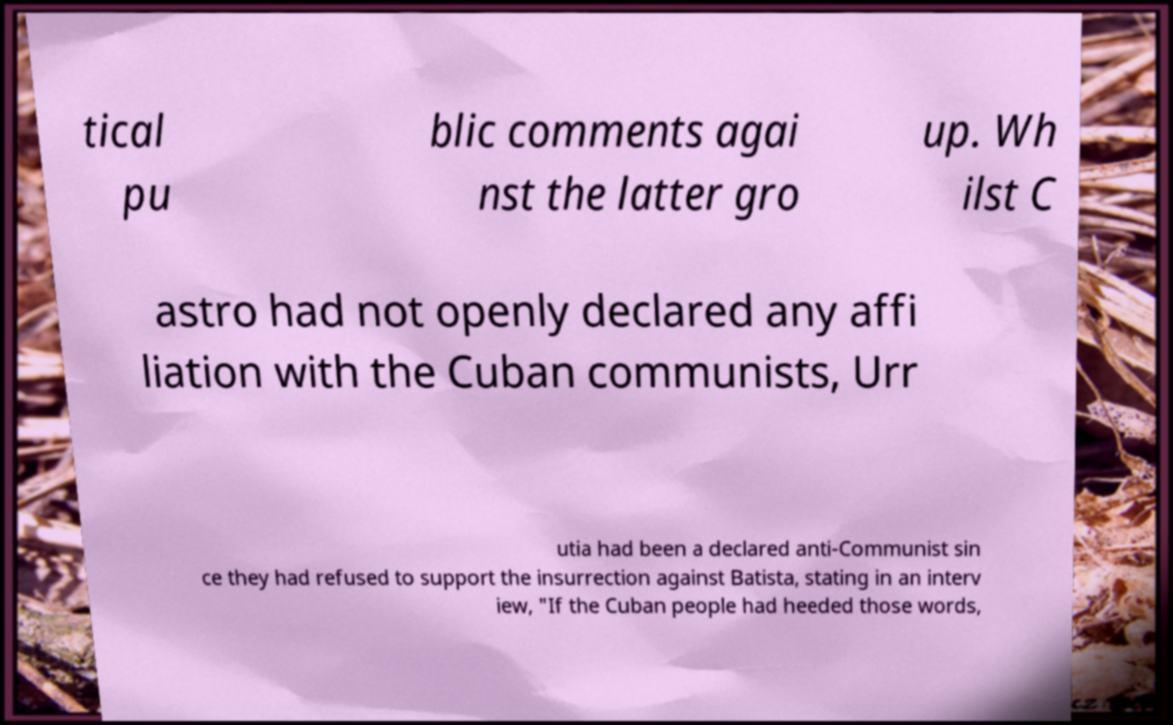Could you extract and type out the text from this image? tical pu blic comments agai nst the latter gro up. Wh ilst C astro had not openly declared any affi liation with the Cuban communists, Urr utia had been a declared anti-Communist sin ce they had refused to support the insurrection against Batista, stating in an interv iew, "If the Cuban people had heeded those words, 